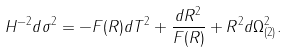<formula> <loc_0><loc_0><loc_500><loc_500>H ^ { - 2 } d \sigma ^ { 2 } = - F ( R ) d T ^ { 2 } + \frac { d R ^ { 2 } } { F ( R ) } + R ^ { 2 } d \Omega _ { ( 2 ) } ^ { 2 } .</formula> 